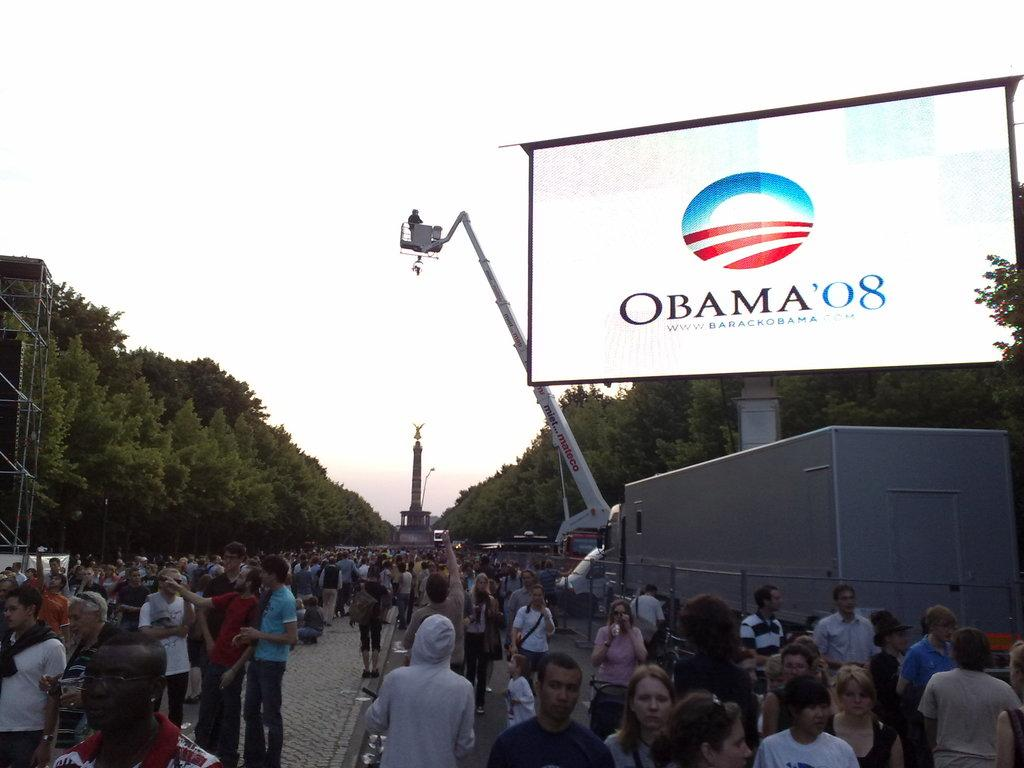How many people are in the image? There is a group of people in the image, but the exact number is not specified. Where are the people standing in the image? The people are standing on a path in the image. What objects can be seen in the image besides the people? There is a pole, a crane, a screen, and trees visible in the image. What part of the natural environment is visible in the image? The sky is visible in the image. What type of chair is being used by the people in the image? There is no chair present in the image; the people are standing on a path. Can you see the sea in the image? No, the sea is not visible in the image. 